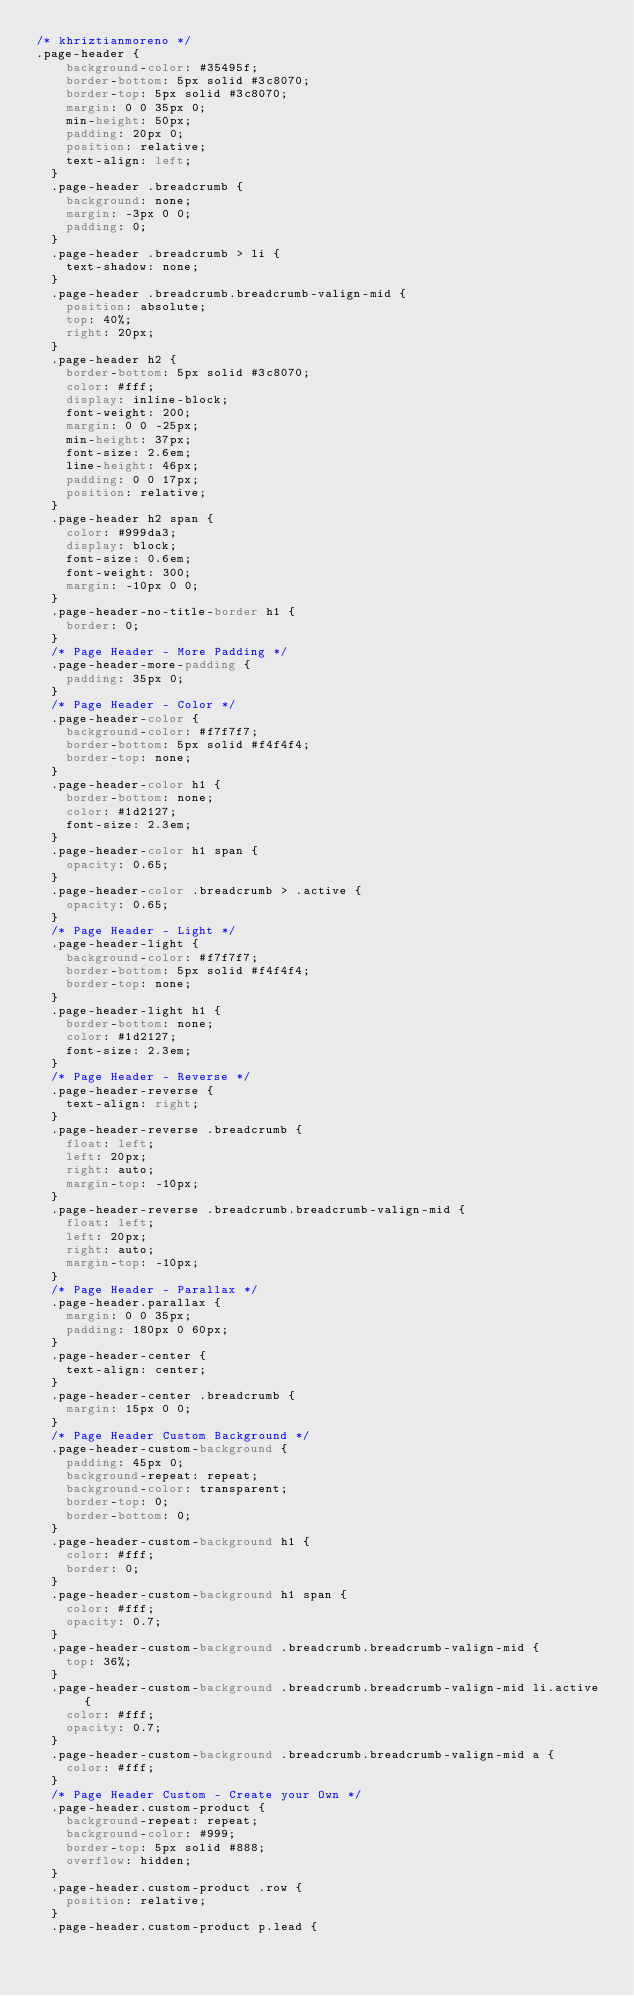Convert code to text. <code><loc_0><loc_0><loc_500><loc_500><_CSS_>/* khriztianmoreno */
.page-header {
    background-color: #35495f;
    border-bottom: 5px solid #3c8070;
    border-top: 5px solid #3c8070;
    margin: 0 0 35px 0;
    min-height: 50px;
    padding: 20px 0;
    position: relative;
    text-align: left;
  }
  .page-header .breadcrumb {
    background: none;
    margin: -3px 0 0;
    padding: 0;
  }
  .page-header .breadcrumb > li {
    text-shadow: none;
  }
  .page-header .breadcrumb.breadcrumb-valign-mid {
    position: absolute;
    top: 40%;
    right: 20px;
  }
  .page-header h2 {
    border-bottom: 5px solid #3c8070;
    color: #fff;
    display: inline-block;
    font-weight: 200;
    margin: 0 0 -25px;
    min-height: 37px;
    font-size: 2.6em;
    line-height: 46px;
    padding: 0 0 17px;
    position: relative;
  }
  .page-header h2 span {
    color: #999da3;
    display: block;
    font-size: 0.6em;
    font-weight: 300;
    margin: -10px 0 0;
  }
  .page-header-no-title-border h1 {
    border: 0;
  }
  /* Page Header - More Padding */
  .page-header-more-padding {
    padding: 35px 0;
  }
  /* Page Header - Color */
  .page-header-color {
    background-color: #f7f7f7;
    border-bottom: 5px solid #f4f4f4;
    border-top: none;
  }
  .page-header-color h1 {
    border-bottom: none;
    color: #1d2127;
    font-size: 2.3em;
  }
  .page-header-color h1 span {
    opacity: 0.65;
  }
  .page-header-color .breadcrumb > .active {
    opacity: 0.65;
  }
  /* Page Header - Light */
  .page-header-light {
    background-color: #f7f7f7;
    border-bottom: 5px solid #f4f4f4;
    border-top: none;
  }
  .page-header-light h1 {
    border-bottom: none;
    color: #1d2127;
    font-size: 2.3em;
  }
  /* Page Header - Reverse */
  .page-header-reverse {
    text-align: right;
  }
  .page-header-reverse .breadcrumb {
    float: left;
    left: 20px;
    right: auto;
    margin-top: -10px;
  }
  .page-header-reverse .breadcrumb.breadcrumb-valign-mid {
    float: left;
    left: 20px;
    right: auto;
    margin-top: -10px;
  }
  /* Page Header - Parallax */
  .page-header.parallax {
    margin: 0 0 35px;
    padding: 180px 0 60px;
  }
  .page-header-center {
    text-align: center;
  }
  .page-header-center .breadcrumb {
    margin: 15px 0 0;
  }
  /* Page Header Custom Background */
  .page-header-custom-background {
    padding: 45px 0;
    background-repeat: repeat;
    background-color: transparent;
    border-top: 0;
    border-bottom: 0;
  }
  .page-header-custom-background h1 {
    color: #fff;
    border: 0;
  }
  .page-header-custom-background h1 span {
    color: #fff;
    opacity: 0.7;
  }
  .page-header-custom-background .breadcrumb.breadcrumb-valign-mid {
    top: 36%;
  }
  .page-header-custom-background .breadcrumb.breadcrumb-valign-mid li.active {
    color: #fff;
    opacity: 0.7;
  }
  .page-header-custom-background .breadcrumb.breadcrumb-valign-mid a {
    color: #fff;
  }
  /* Page Header Custom - Create your Own */
  .page-header.custom-product {
    background-repeat: repeat;
    background-color: #999;
    border-top: 5px solid #888;
    overflow: hidden;
  }
  .page-header.custom-product .row {
    position: relative;
  }
  .page-header.custom-product p.lead {</code> 